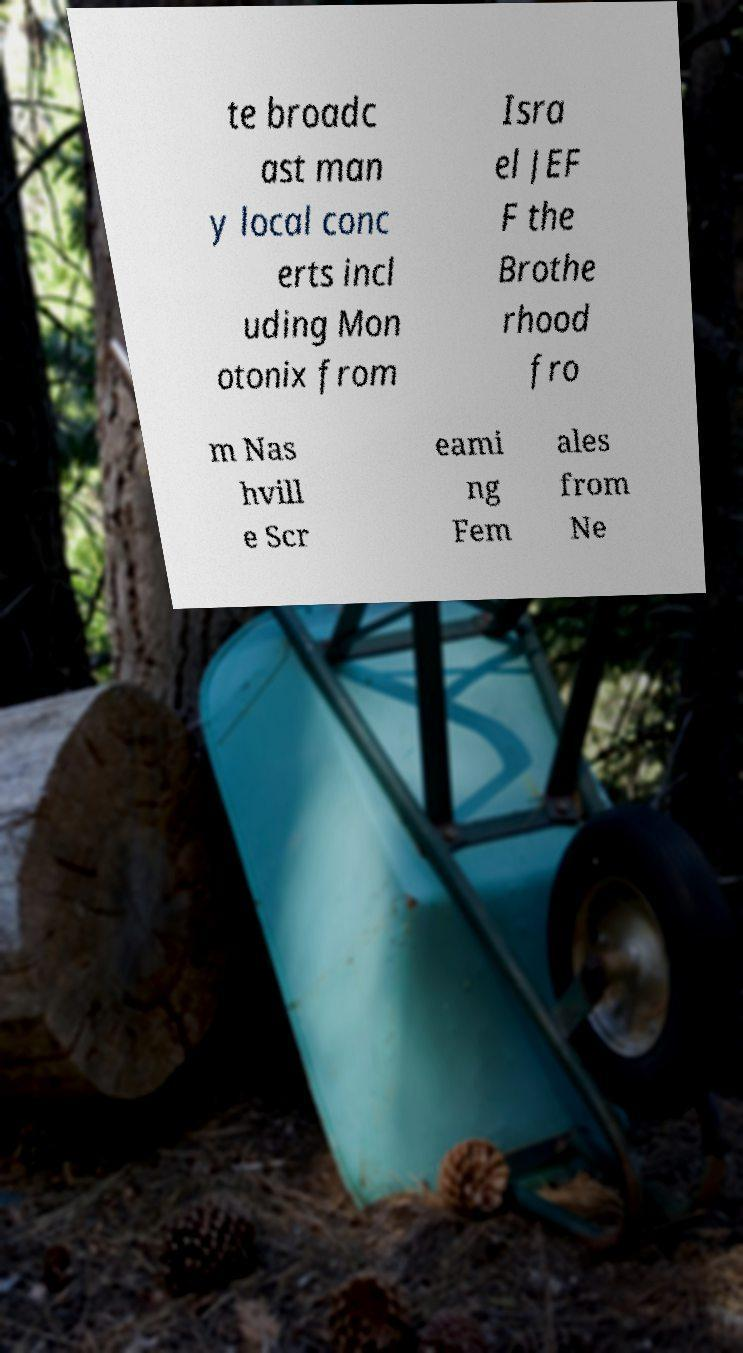Can you read and provide the text displayed in the image?This photo seems to have some interesting text. Can you extract and type it out for me? te broadc ast man y local conc erts incl uding Mon otonix from Isra el JEF F the Brothe rhood fro m Nas hvill e Scr eami ng Fem ales from Ne 